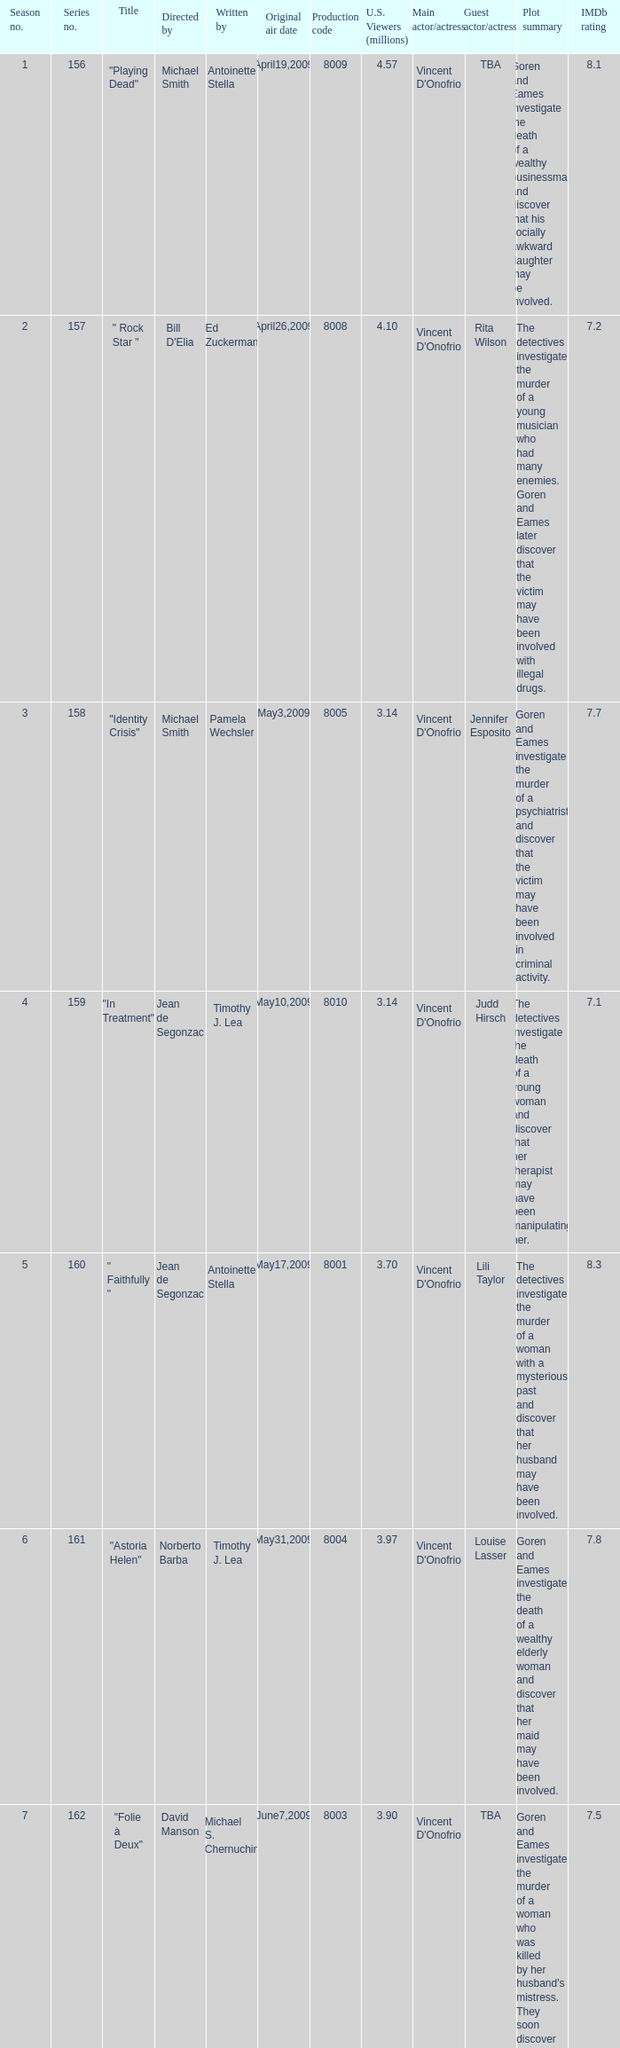How many writers write the episode whose director is Jonathan Herron? 1.0. 